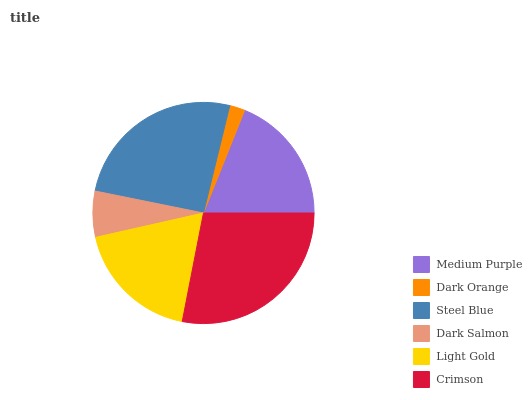Is Dark Orange the minimum?
Answer yes or no. Yes. Is Crimson the maximum?
Answer yes or no. Yes. Is Steel Blue the minimum?
Answer yes or no. No. Is Steel Blue the maximum?
Answer yes or no. No. Is Steel Blue greater than Dark Orange?
Answer yes or no. Yes. Is Dark Orange less than Steel Blue?
Answer yes or no. Yes. Is Dark Orange greater than Steel Blue?
Answer yes or no. No. Is Steel Blue less than Dark Orange?
Answer yes or no. No. Is Medium Purple the high median?
Answer yes or no. Yes. Is Light Gold the low median?
Answer yes or no. Yes. Is Light Gold the high median?
Answer yes or no. No. Is Crimson the low median?
Answer yes or no. No. 